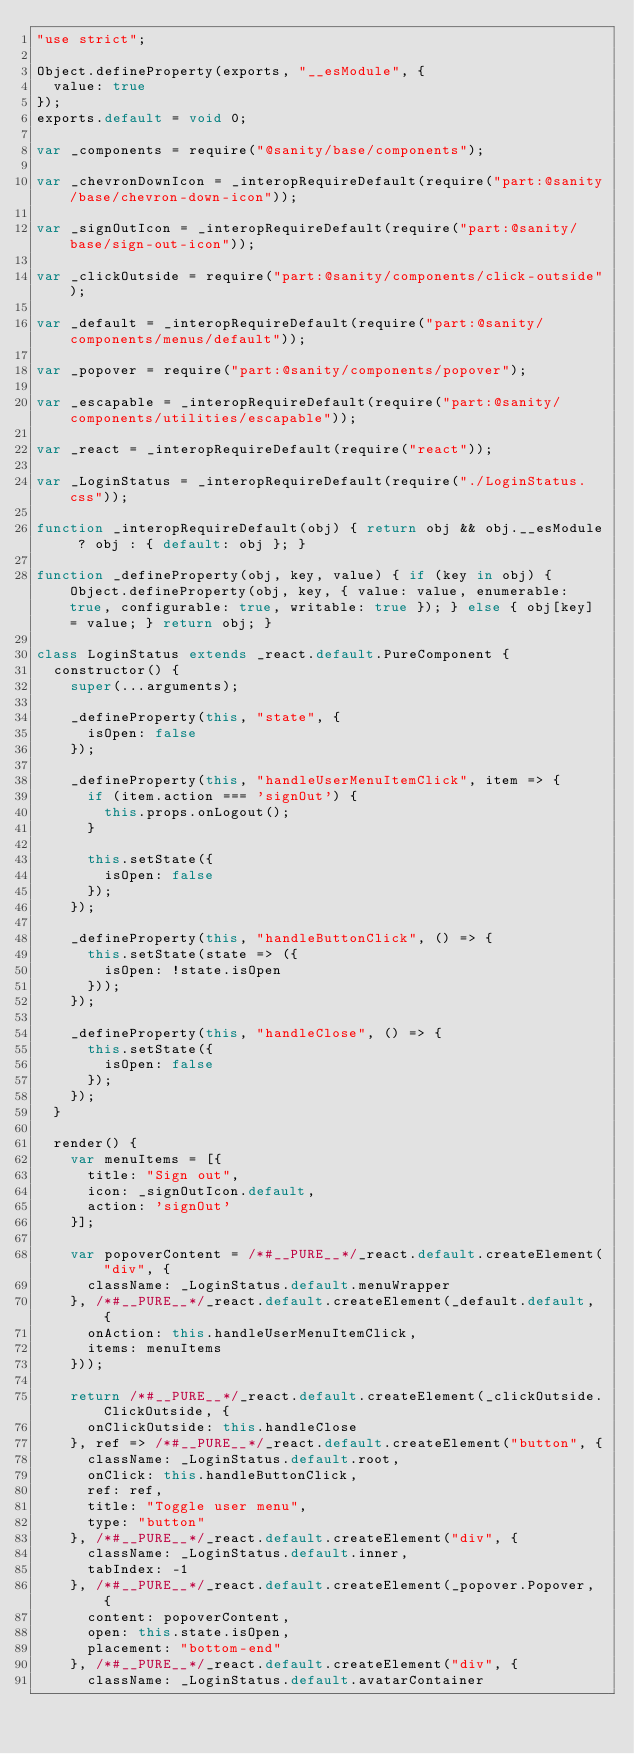Convert code to text. <code><loc_0><loc_0><loc_500><loc_500><_JavaScript_>"use strict";

Object.defineProperty(exports, "__esModule", {
  value: true
});
exports.default = void 0;

var _components = require("@sanity/base/components");

var _chevronDownIcon = _interopRequireDefault(require("part:@sanity/base/chevron-down-icon"));

var _signOutIcon = _interopRequireDefault(require("part:@sanity/base/sign-out-icon"));

var _clickOutside = require("part:@sanity/components/click-outside");

var _default = _interopRequireDefault(require("part:@sanity/components/menus/default"));

var _popover = require("part:@sanity/components/popover");

var _escapable = _interopRequireDefault(require("part:@sanity/components/utilities/escapable"));

var _react = _interopRequireDefault(require("react"));

var _LoginStatus = _interopRequireDefault(require("./LoginStatus.css"));

function _interopRequireDefault(obj) { return obj && obj.__esModule ? obj : { default: obj }; }

function _defineProperty(obj, key, value) { if (key in obj) { Object.defineProperty(obj, key, { value: value, enumerable: true, configurable: true, writable: true }); } else { obj[key] = value; } return obj; }

class LoginStatus extends _react.default.PureComponent {
  constructor() {
    super(...arguments);

    _defineProperty(this, "state", {
      isOpen: false
    });

    _defineProperty(this, "handleUserMenuItemClick", item => {
      if (item.action === 'signOut') {
        this.props.onLogout();
      }

      this.setState({
        isOpen: false
      });
    });

    _defineProperty(this, "handleButtonClick", () => {
      this.setState(state => ({
        isOpen: !state.isOpen
      }));
    });

    _defineProperty(this, "handleClose", () => {
      this.setState({
        isOpen: false
      });
    });
  }

  render() {
    var menuItems = [{
      title: "Sign out",
      icon: _signOutIcon.default,
      action: 'signOut'
    }];

    var popoverContent = /*#__PURE__*/_react.default.createElement("div", {
      className: _LoginStatus.default.menuWrapper
    }, /*#__PURE__*/_react.default.createElement(_default.default, {
      onAction: this.handleUserMenuItemClick,
      items: menuItems
    }));

    return /*#__PURE__*/_react.default.createElement(_clickOutside.ClickOutside, {
      onClickOutside: this.handleClose
    }, ref => /*#__PURE__*/_react.default.createElement("button", {
      className: _LoginStatus.default.root,
      onClick: this.handleButtonClick,
      ref: ref,
      title: "Toggle user menu",
      type: "button"
    }, /*#__PURE__*/_react.default.createElement("div", {
      className: _LoginStatus.default.inner,
      tabIndex: -1
    }, /*#__PURE__*/_react.default.createElement(_popover.Popover, {
      content: popoverContent,
      open: this.state.isOpen,
      placement: "bottom-end"
    }, /*#__PURE__*/_react.default.createElement("div", {
      className: _LoginStatus.default.avatarContainer</code> 